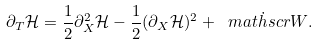Convert formula to latex. <formula><loc_0><loc_0><loc_500><loc_500>\partial _ { T } \mathcal { H } = \frac { 1 } { 2 } \partial _ { X } ^ { 2 } \mathcal { H } - \frac { 1 } { 2 } ( \partial _ { X } \mathcal { H } ) ^ { 2 } + \dot { \ m a t h s c r { W } } .</formula> 